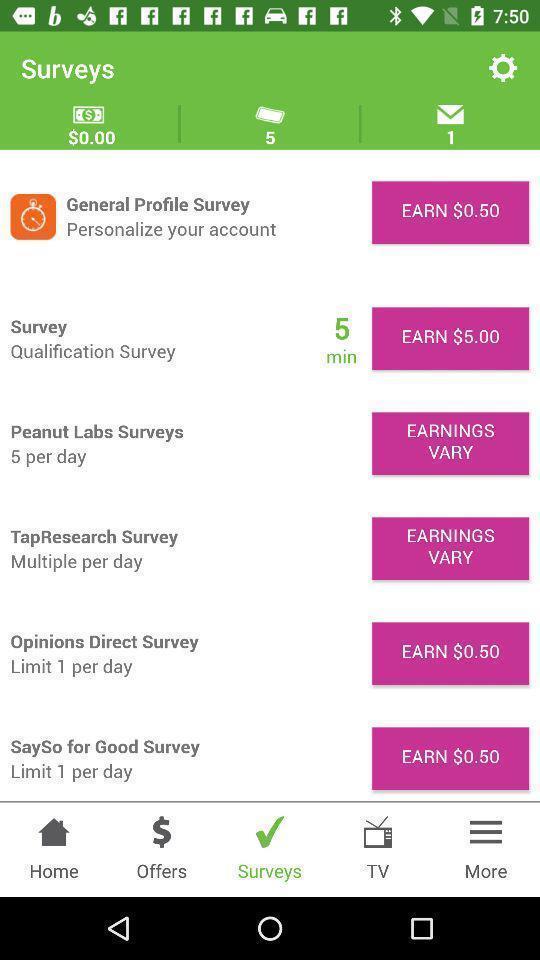Give me a narrative description of this picture. Page displaying with different surveys and earning details. 